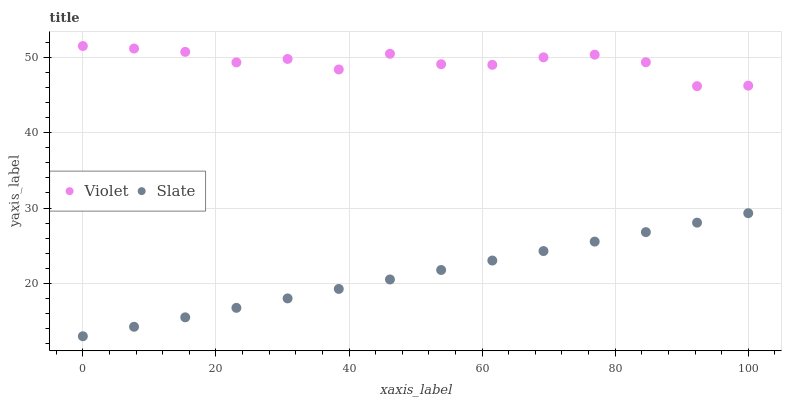Does Slate have the minimum area under the curve?
Answer yes or no. Yes. Does Violet have the maximum area under the curve?
Answer yes or no. Yes. Does Violet have the minimum area under the curve?
Answer yes or no. No. Is Slate the smoothest?
Answer yes or no. Yes. Is Violet the roughest?
Answer yes or no. Yes. Is Violet the smoothest?
Answer yes or no. No. Does Slate have the lowest value?
Answer yes or no. Yes. Does Violet have the lowest value?
Answer yes or no. No. Does Violet have the highest value?
Answer yes or no. Yes. Is Slate less than Violet?
Answer yes or no. Yes. Is Violet greater than Slate?
Answer yes or no. Yes. Does Slate intersect Violet?
Answer yes or no. No. 